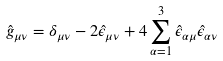Convert formula to latex. <formula><loc_0><loc_0><loc_500><loc_500>\hat { g } _ { \mu \nu } = \delta _ { \mu \nu } - 2 \hat { \epsilon } _ { \mu \nu } + 4 \sum _ { \alpha = 1 } ^ { 3 } \hat { \epsilon } _ { \alpha \mu } \hat { \epsilon } _ { \alpha \nu }</formula> 